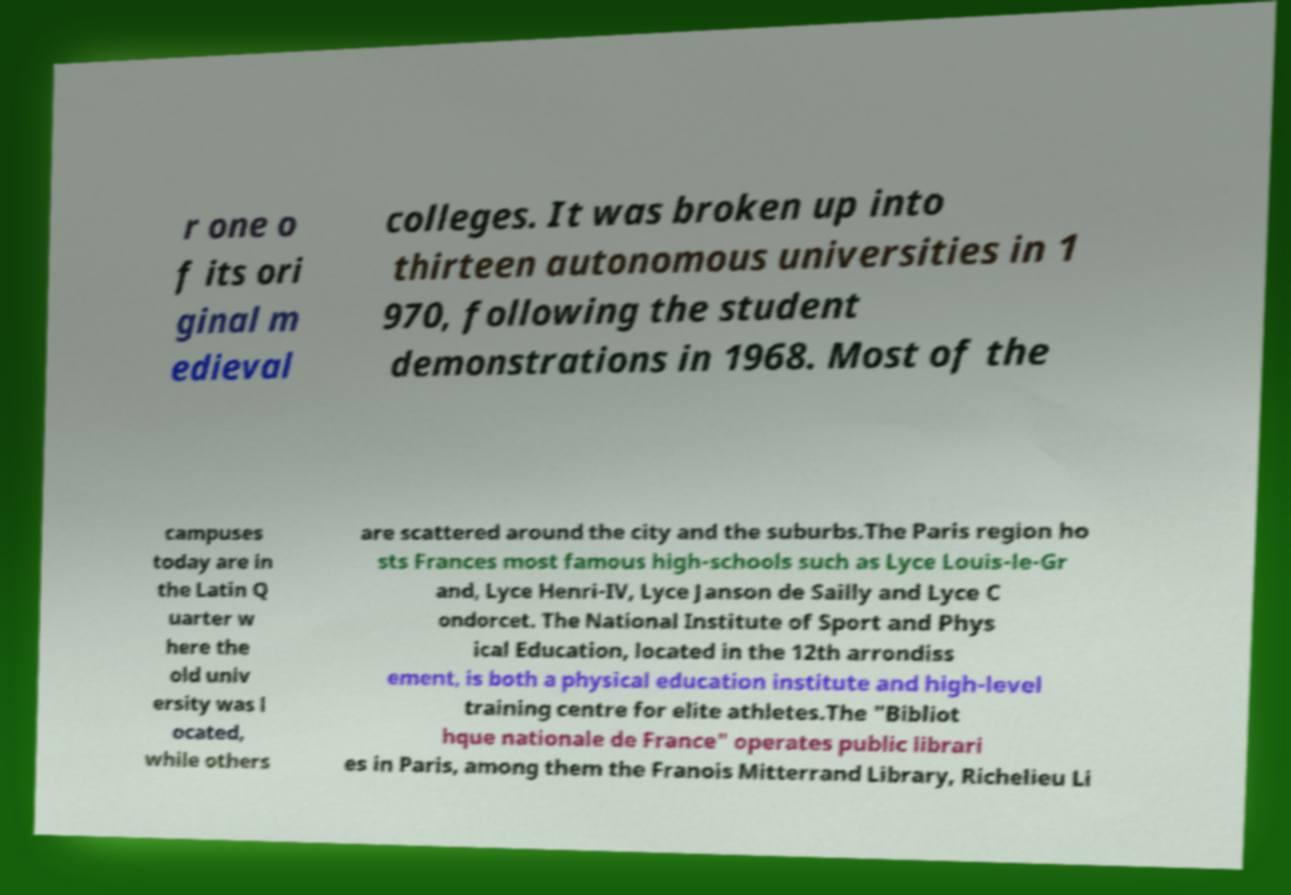I need the written content from this picture converted into text. Can you do that? r one o f its ori ginal m edieval colleges. It was broken up into thirteen autonomous universities in 1 970, following the student demonstrations in 1968. Most of the campuses today are in the Latin Q uarter w here the old univ ersity was l ocated, while others are scattered around the city and the suburbs.The Paris region ho sts Frances most famous high-schools such as Lyce Louis-le-Gr and, Lyce Henri-IV, Lyce Janson de Sailly and Lyce C ondorcet. The National Institute of Sport and Phys ical Education, located in the 12th arrondiss ement, is both a physical education institute and high-level training centre for elite athletes.The "Bibliot hque nationale de France" operates public librari es in Paris, among them the Franois Mitterrand Library, Richelieu Li 